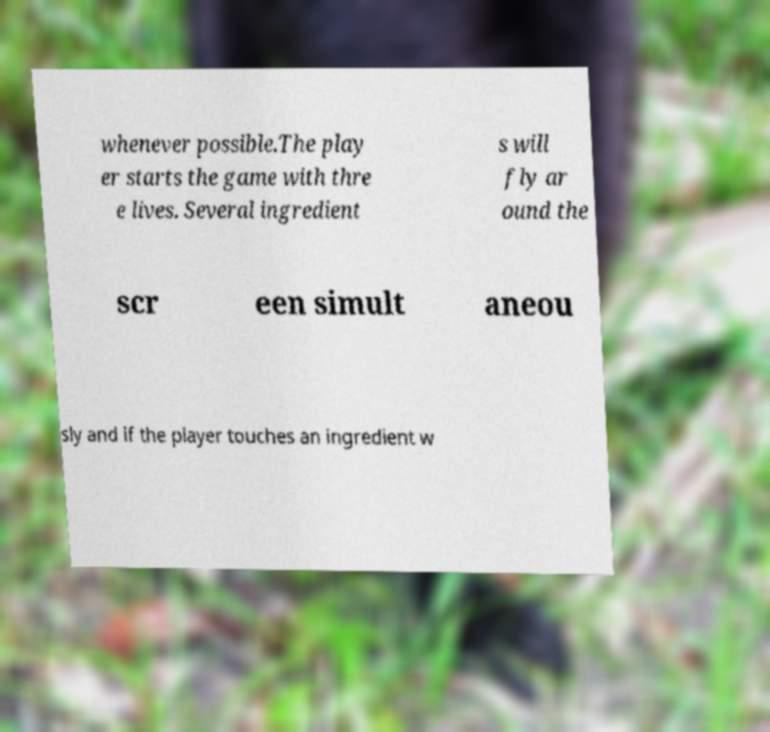Could you extract and type out the text from this image? whenever possible.The play er starts the game with thre e lives. Several ingredient s will fly ar ound the scr een simult aneou sly and if the player touches an ingredient w 